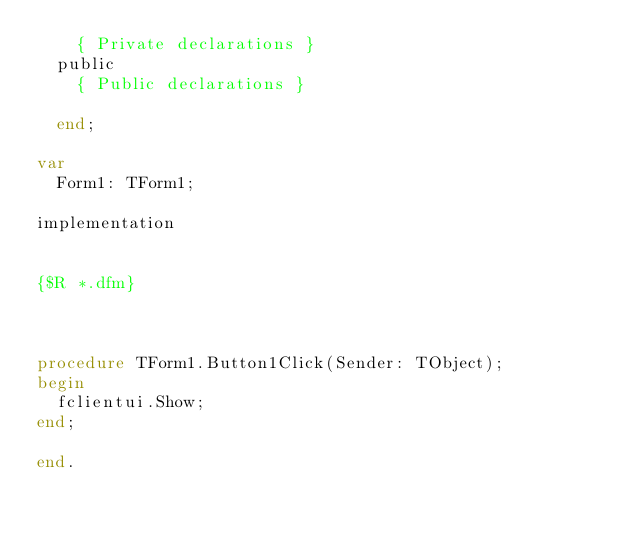Convert code to text. <code><loc_0><loc_0><loc_500><loc_500><_Pascal_>    { Private declarations }
  public
    { Public declarations }

  end;

var
  Form1: TForm1;

implementation


{$R *.dfm}



procedure TForm1.Button1Click(Sender: TObject);
begin
  fclientui.Show;
end;

end.
</code> 